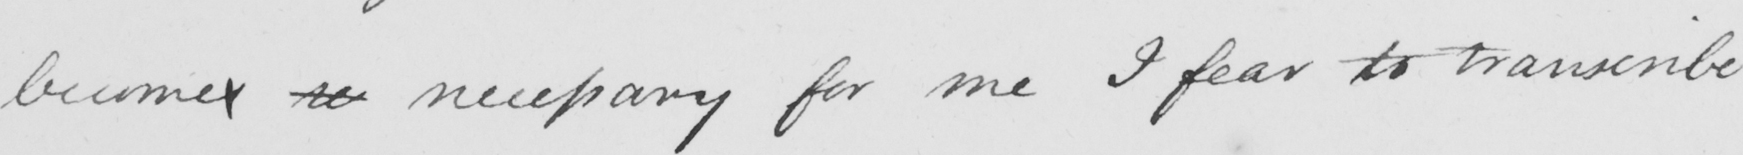What text is written in this handwritten line? becomes se necessary for me I fear to transcribe 